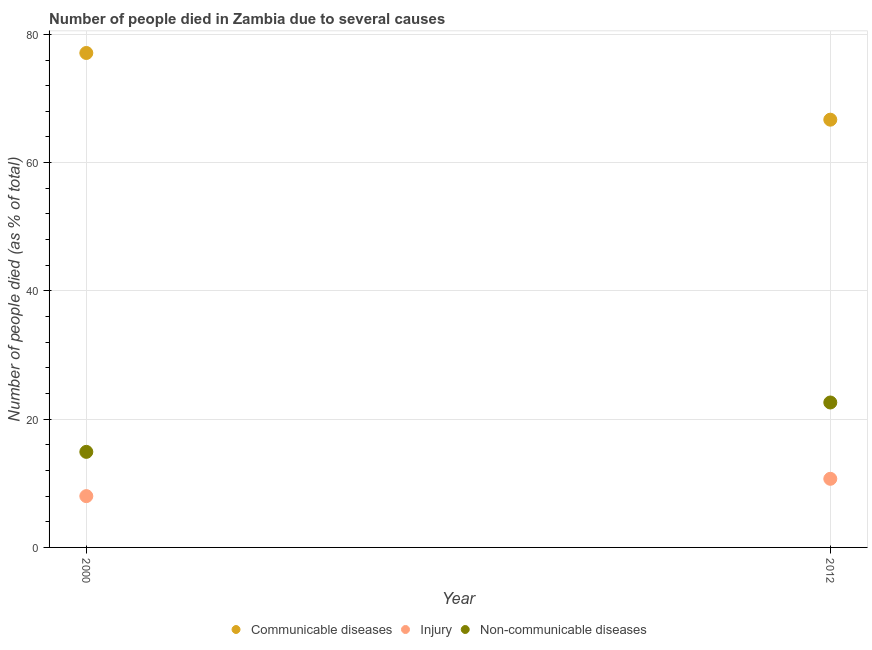Is the number of dotlines equal to the number of legend labels?
Ensure brevity in your answer.  Yes. What is the number of people who died of communicable diseases in 2012?
Keep it short and to the point. 66.7. Across all years, what is the maximum number of people who dies of non-communicable diseases?
Provide a short and direct response. 22.6. Across all years, what is the minimum number of people who died of communicable diseases?
Provide a succinct answer. 66.7. What is the total number of people who died of injury in the graph?
Your answer should be compact. 18.7. What is the difference between the number of people who dies of non-communicable diseases in 2000 and that in 2012?
Provide a short and direct response. -7.7. What is the difference between the number of people who dies of non-communicable diseases in 2012 and the number of people who died of injury in 2000?
Keep it short and to the point. 14.6. What is the average number of people who dies of non-communicable diseases per year?
Ensure brevity in your answer.  18.75. In the year 2012, what is the difference between the number of people who died of communicable diseases and number of people who dies of non-communicable diseases?
Your response must be concise. 44.1. What is the ratio of the number of people who died of injury in 2000 to that in 2012?
Provide a short and direct response. 0.75. Is the number of people who dies of non-communicable diseases in 2000 less than that in 2012?
Offer a very short reply. Yes. In how many years, is the number of people who died of communicable diseases greater than the average number of people who died of communicable diseases taken over all years?
Provide a short and direct response. 1. How many years are there in the graph?
Ensure brevity in your answer.  2. What is the difference between two consecutive major ticks on the Y-axis?
Your response must be concise. 20. Are the values on the major ticks of Y-axis written in scientific E-notation?
Ensure brevity in your answer.  No. Does the graph contain grids?
Ensure brevity in your answer.  Yes. What is the title of the graph?
Give a very brief answer. Number of people died in Zambia due to several causes. What is the label or title of the Y-axis?
Your response must be concise. Number of people died (as % of total). What is the Number of people died (as % of total) in Communicable diseases in 2000?
Offer a very short reply. 77.1. What is the Number of people died (as % of total) of Injury in 2000?
Give a very brief answer. 8. What is the Number of people died (as % of total) of Communicable diseases in 2012?
Your response must be concise. 66.7. What is the Number of people died (as % of total) in Non-communicable diseases in 2012?
Provide a short and direct response. 22.6. Across all years, what is the maximum Number of people died (as % of total) of Communicable diseases?
Keep it short and to the point. 77.1. Across all years, what is the maximum Number of people died (as % of total) in Non-communicable diseases?
Your answer should be very brief. 22.6. Across all years, what is the minimum Number of people died (as % of total) of Communicable diseases?
Offer a terse response. 66.7. What is the total Number of people died (as % of total) in Communicable diseases in the graph?
Provide a short and direct response. 143.8. What is the total Number of people died (as % of total) in Injury in the graph?
Your answer should be compact. 18.7. What is the total Number of people died (as % of total) in Non-communicable diseases in the graph?
Keep it short and to the point. 37.5. What is the difference between the Number of people died (as % of total) in Communicable diseases in 2000 and that in 2012?
Provide a short and direct response. 10.4. What is the difference between the Number of people died (as % of total) in Communicable diseases in 2000 and the Number of people died (as % of total) in Injury in 2012?
Make the answer very short. 66.4. What is the difference between the Number of people died (as % of total) of Communicable diseases in 2000 and the Number of people died (as % of total) of Non-communicable diseases in 2012?
Your response must be concise. 54.5. What is the difference between the Number of people died (as % of total) of Injury in 2000 and the Number of people died (as % of total) of Non-communicable diseases in 2012?
Give a very brief answer. -14.6. What is the average Number of people died (as % of total) in Communicable diseases per year?
Provide a short and direct response. 71.9. What is the average Number of people died (as % of total) of Injury per year?
Provide a short and direct response. 9.35. What is the average Number of people died (as % of total) in Non-communicable diseases per year?
Your response must be concise. 18.75. In the year 2000, what is the difference between the Number of people died (as % of total) in Communicable diseases and Number of people died (as % of total) in Injury?
Ensure brevity in your answer.  69.1. In the year 2000, what is the difference between the Number of people died (as % of total) of Communicable diseases and Number of people died (as % of total) of Non-communicable diseases?
Your answer should be very brief. 62.2. In the year 2012, what is the difference between the Number of people died (as % of total) of Communicable diseases and Number of people died (as % of total) of Non-communicable diseases?
Provide a short and direct response. 44.1. What is the ratio of the Number of people died (as % of total) of Communicable diseases in 2000 to that in 2012?
Make the answer very short. 1.16. What is the ratio of the Number of people died (as % of total) in Injury in 2000 to that in 2012?
Offer a terse response. 0.75. What is the ratio of the Number of people died (as % of total) of Non-communicable diseases in 2000 to that in 2012?
Your answer should be compact. 0.66. What is the difference between the highest and the second highest Number of people died (as % of total) in Communicable diseases?
Offer a very short reply. 10.4. What is the difference between the highest and the second highest Number of people died (as % of total) of Injury?
Provide a succinct answer. 2.7. What is the difference between the highest and the lowest Number of people died (as % of total) of Communicable diseases?
Provide a short and direct response. 10.4. What is the difference between the highest and the lowest Number of people died (as % of total) of Injury?
Offer a terse response. 2.7. What is the difference between the highest and the lowest Number of people died (as % of total) in Non-communicable diseases?
Offer a terse response. 7.7. 